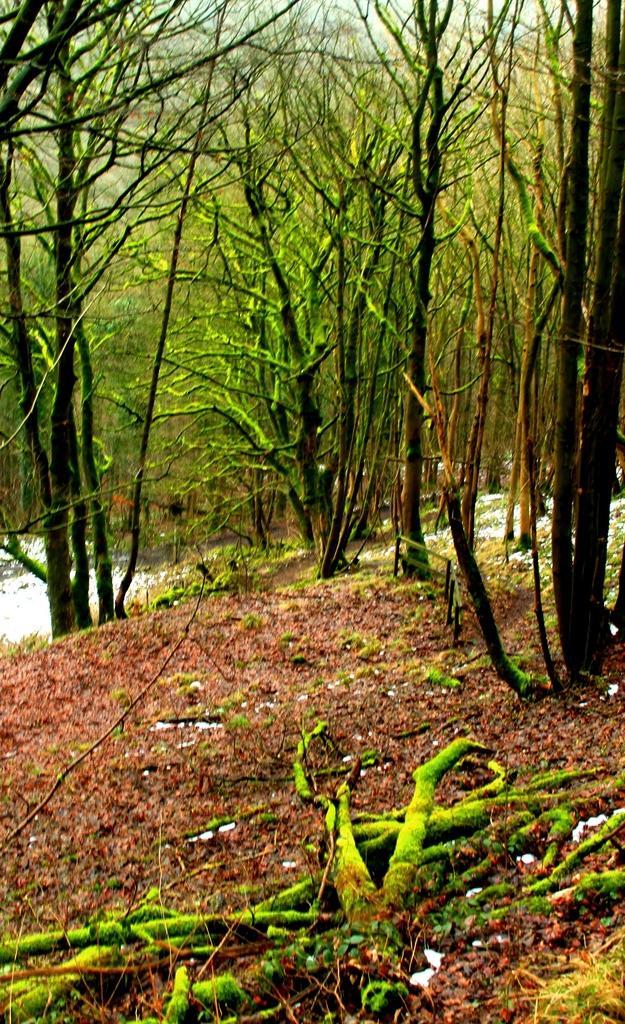Please provide a concise description of this image. In this image there are tall trees in the middle. At the bottom there is a ground on which there are tree stems and dry leaves. 